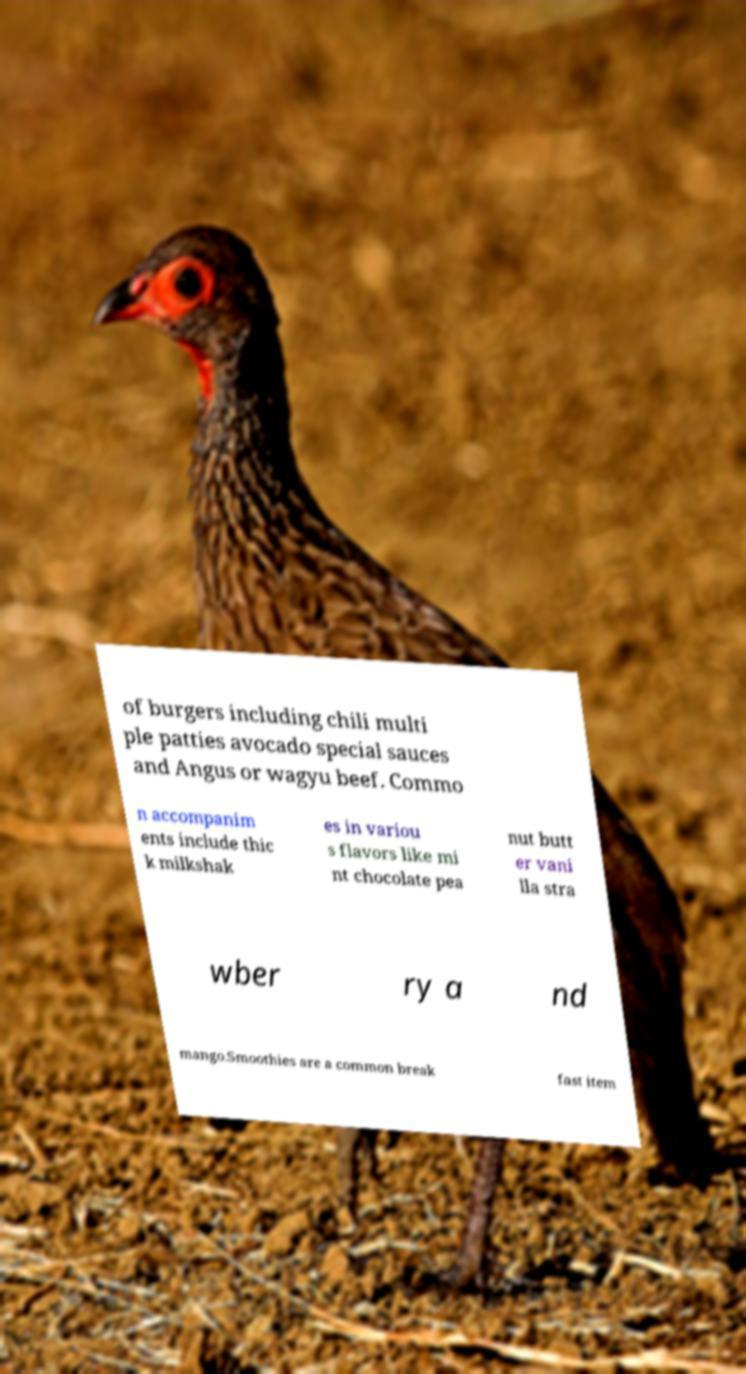Could you assist in decoding the text presented in this image and type it out clearly? of burgers including chili multi ple patties avocado special sauces and Angus or wagyu beef. Commo n accompanim ents include thic k milkshak es in variou s flavors like mi nt chocolate pea nut butt er vani lla stra wber ry a nd mango.Smoothies are a common break fast item 